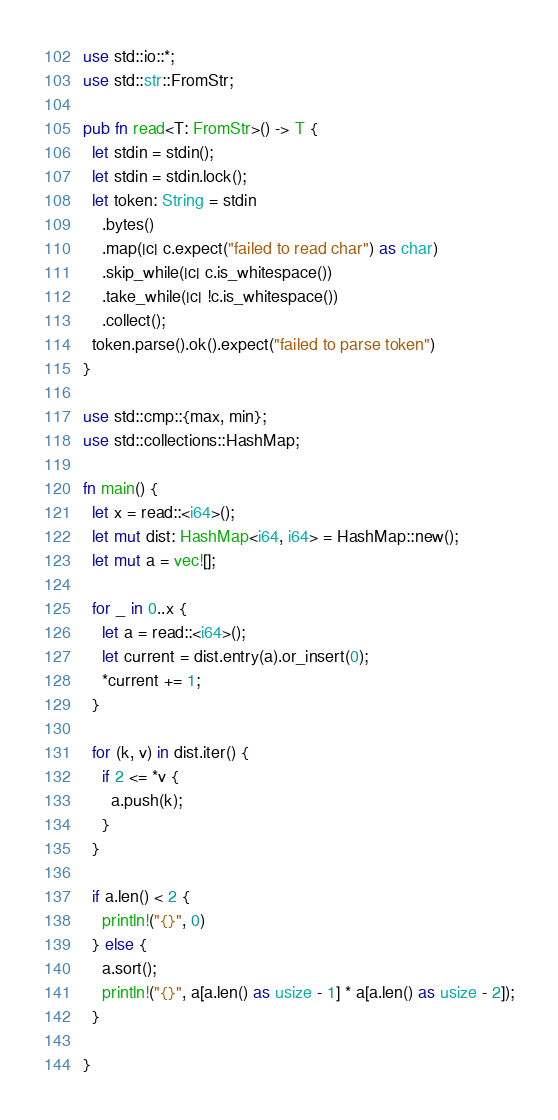Convert code to text. <code><loc_0><loc_0><loc_500><loc_500><_Rust_>
use std::io::*;
use std::str::FromStr;

pub fn read<T: FromStr>() -> T {
  let stdin = stdin();
  let stdin = stdin.lock();
  let token: String = stdin
    .bytes()
    .map(|c| c.expect("failed to read char") as char)
    .skip_while(|c| c.is_whitespace())
    .take_while(|c| !c.is_whitespace())
    .collect();
  token.parse().ok().expect("failed to parse token")
}

use std::cmp::{max, min};
use std::collections::HashMap;

fn main() {
  let x = read::<i64>();
  let mut dist: HashMap<i64, i64> = HashMap::new();
  let mut a = vec![];

  for _ in 0..x {
    let a = read::<i64>();
    let current = dist.entry(a).or_insert(0);
    *current += 1;
  }

  for (k, v) in dist.iter() {
    if 2 <= *v {
      a.push(k);
    }
  }

  if a.len() < 2 {
    println!("{}", 0)
  } else {
    a.sort();
    println!("{}", a[a.len() as usize - 1] * a[a.len() as usize - 2]);
  }

}

</code> 